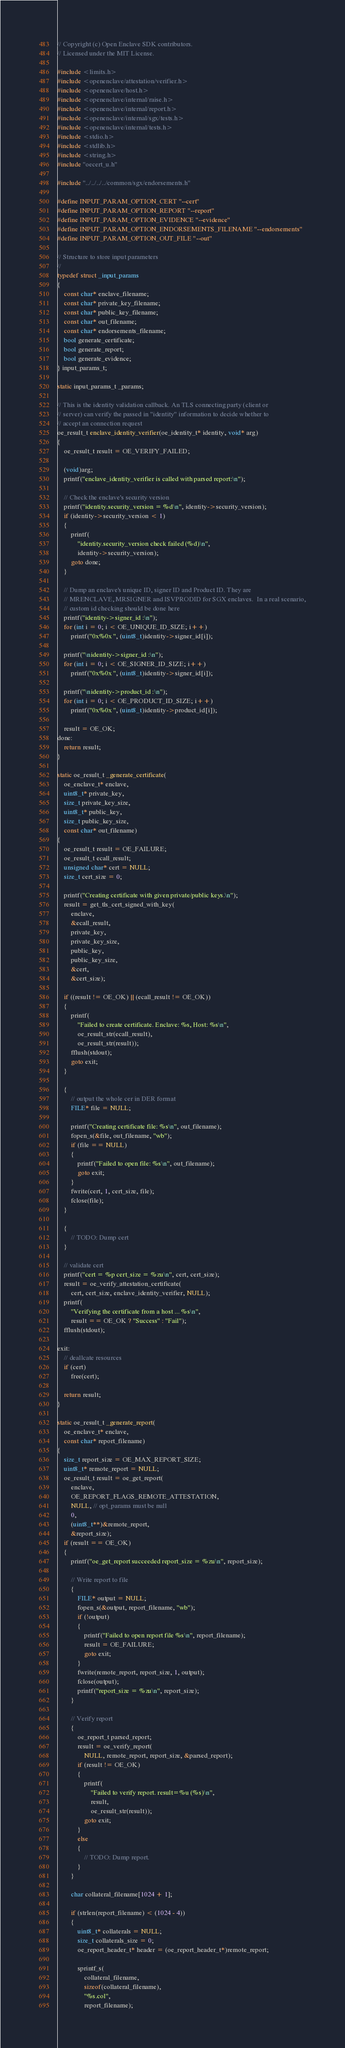Convert code to text. <code><loc_0><loc_0><loc_500><loc_500><_C++_>// Copyright (c) Open Enclave SDK contributors.
// Licensed under the MIT License.

#include <limits.h>
#include <openenclave/attestation/verifier.h>
#include <openenclave/host.h>
#include <openenclave/internal/raise.h>
#include <openenclave/internal/report.h>
#include <openenclave/internal/sgx/tests.h>
#include <openenclave/internal/tests.h>
#include <stdio.h>
#include <stdlib.h>
#include <string.h>
#include "oecert_u.h"

#include "../../../../common/sgx/endorsements.h"

#define INPUT_PARAM_OPTION_CERT "--cert"
#define INPUT_PARAM_OPTION_REPORT "--report"
#define INPUT_PARAM_OPTION_EVIDENCE "--evidence"
#define INPUT_PARAM_OPTION_ENDORSEMENTS_FILENAME "--endorsements"
#define INPUT_PARAM_OPTION_OUT_FILE "--out"

// Structure to store input parameters
//
typedef struct _input_params
{
    const char* enclave_filename;
    const char* private_key_filename;
    const char* public_key_filename;
    const char* out_filename;
    const char* endorsements_filename;
    bool generate_certificate;
    bool generate_report;
    bool generate_evidence;
} input_params_t;

static input_params_t _params;

// This is the identity validation callback. An TLS connecting party (client or
// server) can verify the passed in "identity" information to decide whether to
// accept an connection request
oe_result_t enclave_identity_verifier(oe_identity_t* identity, void* arg)
{
    oe_result_t result = OE_VERIFY_FAILED;

    (void)arg;
    printf("enclave_identity_verifier is called with parsed report:\n");

    // Check the enclave's security version
    printf("identity.security_version = %d\n", identity->security_version);
    if (identity->security_version < 1)
    {
        printf(
            "identity.security_version check failed (%d)\n",
            identity->security_version);
        goto done;
    }

    // Dump an enclave's unique ID, signer ID and Product ID. They are
    // MRENCLAVE, MRSIGNER and ISVPRODID for SGX enclaves.  In a real scenario,
    // custom id checking should be done here
    printf("identity->signer_id :\n");
    for (int i = 0; i < OE_UNIQUE_ID_SIZE; i++)
        printf("0x%0x ", (uint8_t)identity->signer_id[i]);

    printf("\nidentity->signer_id :\n");
    for (int i = 0; i < OE_SIGNER_ID_SIZE; i++)
        printf("0x%0x ", (uint8_t)identity->signer_id[i]);

    printf("\nidentity->product_id :\n");
    for (int i = 0; i < OE_PRODUCT_ID_SIZE; i++)
        printf("0x%0x ", (uint8_t)identity->product_id[i]);

    result = OE_OK;
done:
    return result;
}

static oe_result_t _generate_certificate(
    oe_enclave_t* enclave,
    uint8_t* private_key,
    size_t private_key_size,
    uint8_t* public_key,
    size_t public_key_size,
    const char* out_filename)
{
    oe_result_t result = OE_FAILURE;
    oe_result_t ecall_result;
    unsigned char* cert = NULL;
    size_t cert_size = 0;

    printf("Creating certificate with given private/public keys.\n");
    result = get_tls_cert_signed_with_key(
        enclave,
        &ecall_result,
        private_key,
        private_key_size,
        public_key,
        public_key_size,
        &cert,
        &cert_size);

    if ((result != OE_OK) || (ecall_result != OE_OK))
    {
        printf(
            "Failed to create certificate. Enclave: %s, Host: %s\n",
            oe_result_str(ecall_result),
            oe_result_str(result));
        fflush(stdout);
        goto exit;
    }

    {
        // output the whole cer in DER format
        FILE* file = NULL;

        printf("Creating certificate file: %s\n", out_filename);
        fopen_s(&file, out_filename, "wb");
        if (file == NULL)
        {
            printf("Failed to open file: %s\n", out_filename);
            goto exit;
        }
        fwrite(cert, 1, cert_size, file);
        fclose(file);
    }

    {
        // TODO: Dump cert
    }

    // validate cert
    printf("cert = %p cert_size = %zu\n", cert, cert_size);
    result = oe_verify_attestation_certificate(
        cert, cert_size, enclave_identity_verifier, NULL);
    printf(
        "Verifying the certificate from a host ... %s\n",
        result == OE_OK ? "Success" : "Fail");
    fflush(stdout);

exit:
    // deallcate resources
    if (cert)
        free(cert);

    return result;
}

static oe_result_t _generate_report(
    oe_enclave_t* enclave,
    const char* report_filename)
{
    size_t report_size = OE_MAX_REPORT_SIZE;
    uint8_t* remote_report = NULL;
    oe_result_t result = oe_get_report(
        enclave,
        OE_REPORT_FLAGS_REMOTE_ATTESTATION,
        NULL, // opt_params must be null
        0,
        (uint8_t**)&remote_report,
        &report_size);
    if (result == OE_OK)
    {
        printf("oe_get_report succeeded report_size = %zu\n", report_size);

        // Write report to file
        {
            FILE* output = NULL;
            fopen_s(&output, report_filename, "wb");
            if (!output)
            {
                printf("Failed to open report file %s\n", report_filename);
                result = OE_FAILURE;
                goto exit;
            }
            fwrite(remote_report, report_size, 1, output);
            fclose(output);
            printf("report_size = %zu\n", report_size);
        }

        // Verify report
        {
            oe_report_t parsed_report;
            result = oe_verify_report(
                NULL, remote_report, report_size, &parsed_report);
            if (result != OE_OK)
            {
                printf(
                    "Failed to verify report. result=%u (%s)\n",
                    result,
                    oe_result_str(result));
                goto exit;
            }
            else
            {
                // TODO: Dump report.
            }
        }

        char collateral_filename[1024 + 1];

        if (strlen(report_filename) < (1024 - 4))
        {
            uint8_t* collaterals = NULL;
            size_t collaterals_size = 0;
            oe_report_header_t* header = (oe_report_header_t*)remote_report;

            sprintf_s(
                collateral_filename,
                sizeof(collateral_filename),
                "%s.col",
                report_filename);</code> 